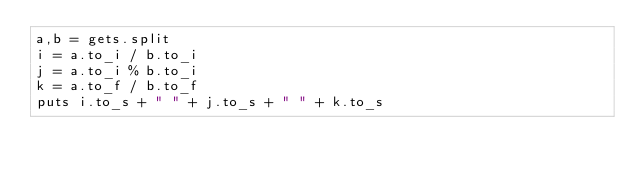<code> <loc_0><loc_0><loc_500><loc_500><_Ruby_>a,b = gets.split
i = a.to_i / b.to_i
j = a.to_i % b.to_i
k = a.to_f / b.to_f
puts i.to_s + " " + j.to_s + " " + k.to_s</code> 